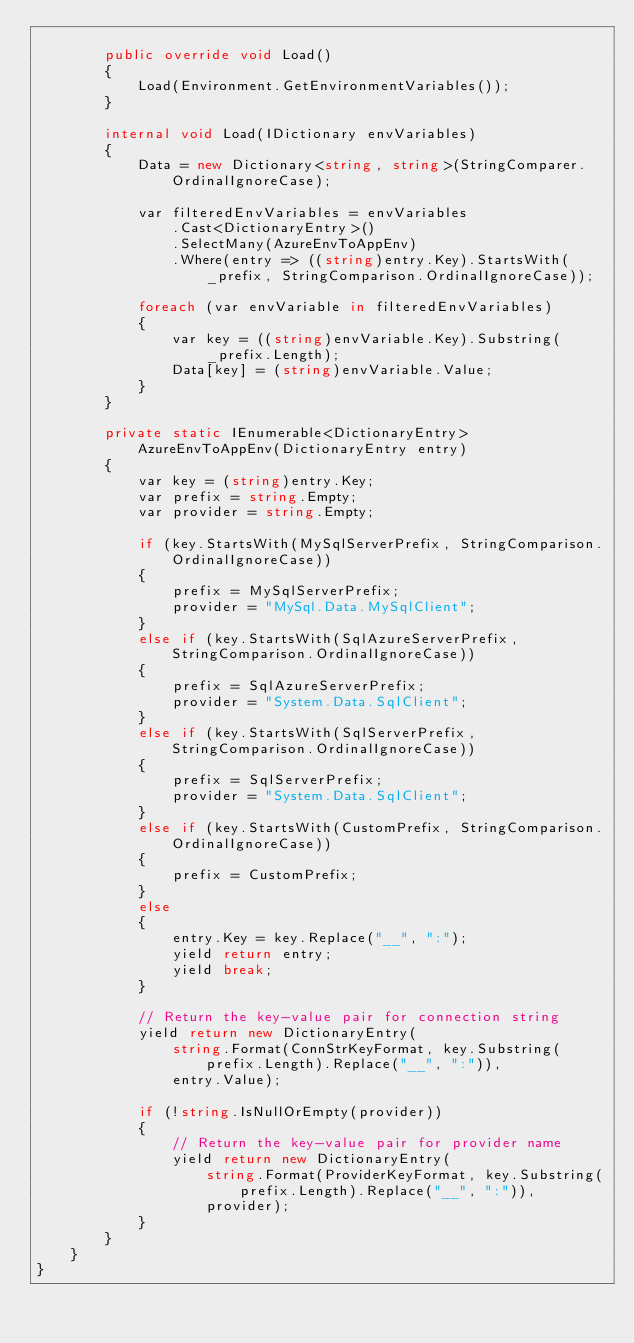Convert code to text. <code><loc_0><loc_0><loc_500><loc_500><_C#_>
        public override void Load()
        {
            Load(Environment.GetEnvironmentVariables());
        }

        internal void Load(IDictionary envVariables)
        {
            Data = new Dictionary<string, string>(StringComparer.OrdinalIgnoreCase);

            var filteredEnvVariables = envVariables
                .Cast<DictionaryEntry>()
                .SelectMany(AzureEnvToAppEnv)
                .Where(entry => ((string)entry.Key).StartsWith(_prefix, StringComparison.OrdinalIgnoreCase));

            foreach (var envVariable in filteredEnvVariables)
            {
                var key = ((string)envVariable.Key).Substring(_prefix.Length);
                Data[key] = (string)envVariable.Value;
            }
        }

        private static IEnumerable<DictionaryEntry> AzureEnvToAppEnv(DictionaryEntry entry)
        {
            var key = (string)entry.Key;
            var prefix = string.Empty;
            var provider = string.Empty;

            if (key.StartsWith(MySqlServerPrefix, StringComparison.OrdinalIgnoreCase))
            {
                prefix = MySqlServerPrefix;
                provider = "MySql.Data.MySqlClient";
            }
            else if (key.StartsWith(SqlAzureServerPrefix, StringComparison.OrdinalIgnoreCase))
            {
                prefix = SqlAzureServerPrefix;
                provider = "System.Data.SqlClient";
            }
            else if (key.StartsWith(SqlServerPrefix, StringComparison.OrdinalIgnoreCase))
            {
                prefix = SqlServerPrefix;
                provider = "System.Data.SqlClient";
            }
            else if (key.StartsWith(CustomPrefix, StringComparison.OrdinalIgnoreCase))
            {
                prefix = CustomPrefix;
            }
            else
            {
                entry.Key = key.Replace("__", ":");
                yield return entry;
                yield break;
            }

            // Return the key-value pair for connection string
            yield return new DictionaryEntry(
                string.Format(ConnStrKeyFormat, key.Substring(prefix.Length).Replace("__", ":")),
                entry.Value);

            if (!string.IsNullOrEmpty(provider))
            {
                // Return the key-value pair for provider name
                yield return new DictionaryEntry(
                    string.Format(ProviderKeyFormat, key.Substring(prefix.Length).Replace("__", ":")),
                    provider);
            }
        }
    }
}
</code> 